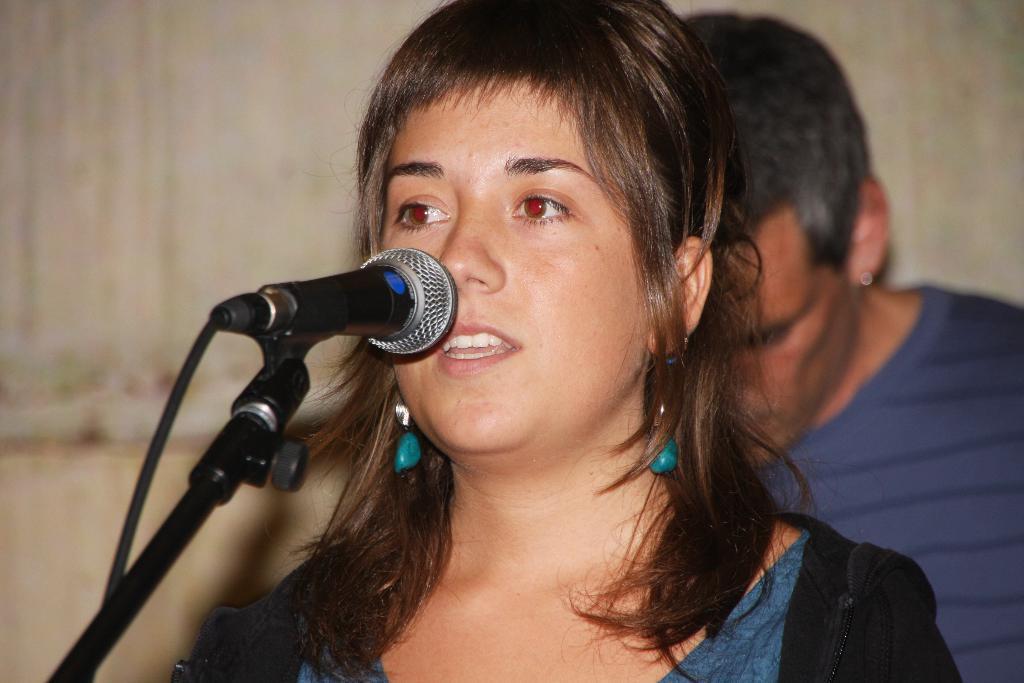Describe this image in one or two sentences. In this picture I can see a woman standing and singing with the help of a microphone and I can see a man standing on the back and looks like a wall in the background. 